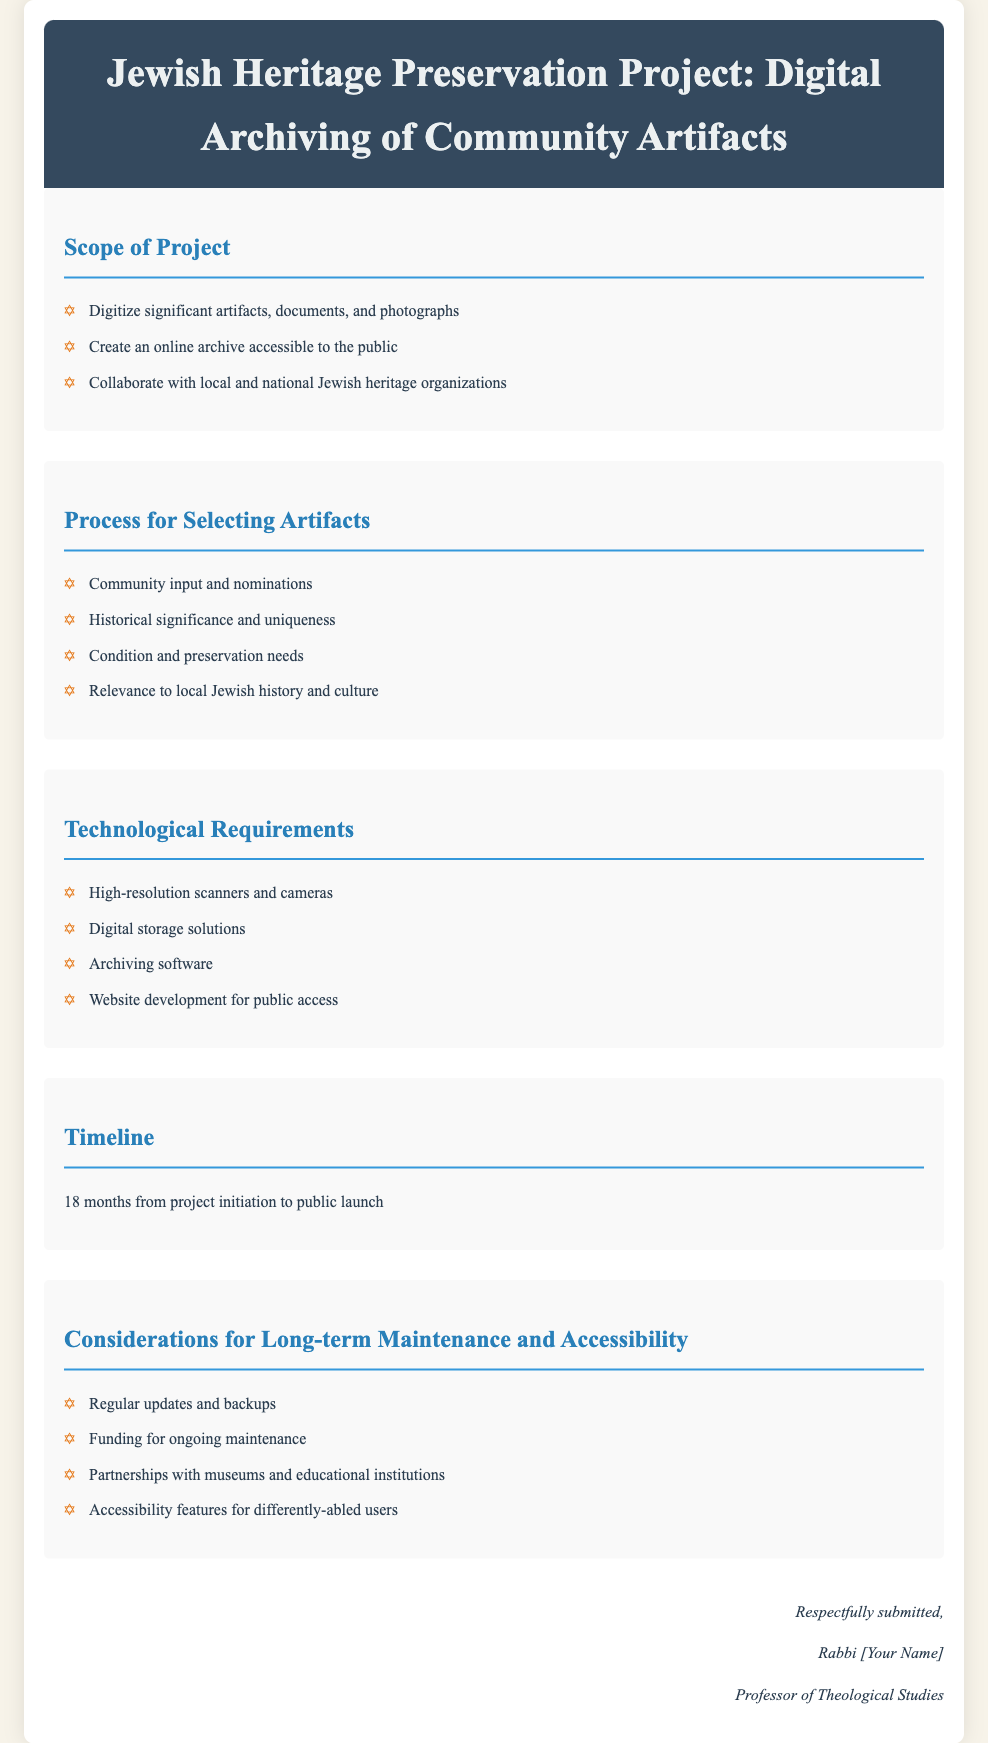What is the title of the project? The title of the project is explicitly stated at the top of the document.
Answer: Jewish Heritage Preservation Project: Digital Archiving of Community Artifacts What is the timeline for the project? The document provides a specific duration for the project timeline.
Answer: 18 months What will be digitized in the project? The document outlines what types of items will be processed in the project scope.
Answer: Significant artifacts, documents, and photographs What are the technological requirements listed? The document lists specific technological tools needed for the project.
Answer: High-resolution scanners and cameras, digital storage solutions, archiving software, website development for public access What is the main consideration for long-term maintenance? The document mentions essential factors for future maintenance of the project.
Answer: Regular updates and backups How will artifacts be selected? The document elaborates on the criteria used to choose artifacts for the project.
Answer: Community input and nominations, historical significance and uniqueness, condition and preservation needs, relevance to local Jewish history and culture Who submitted the proposal? The author's name is indicated at the bottom of the document, specifying the individual who submitted the proposal.
Answer: Rabbi [Your Name] What is the purpose of creating an online archive? The document expresses the goal of the online archive regarding accessibility.
Answer: Accessible to the public 